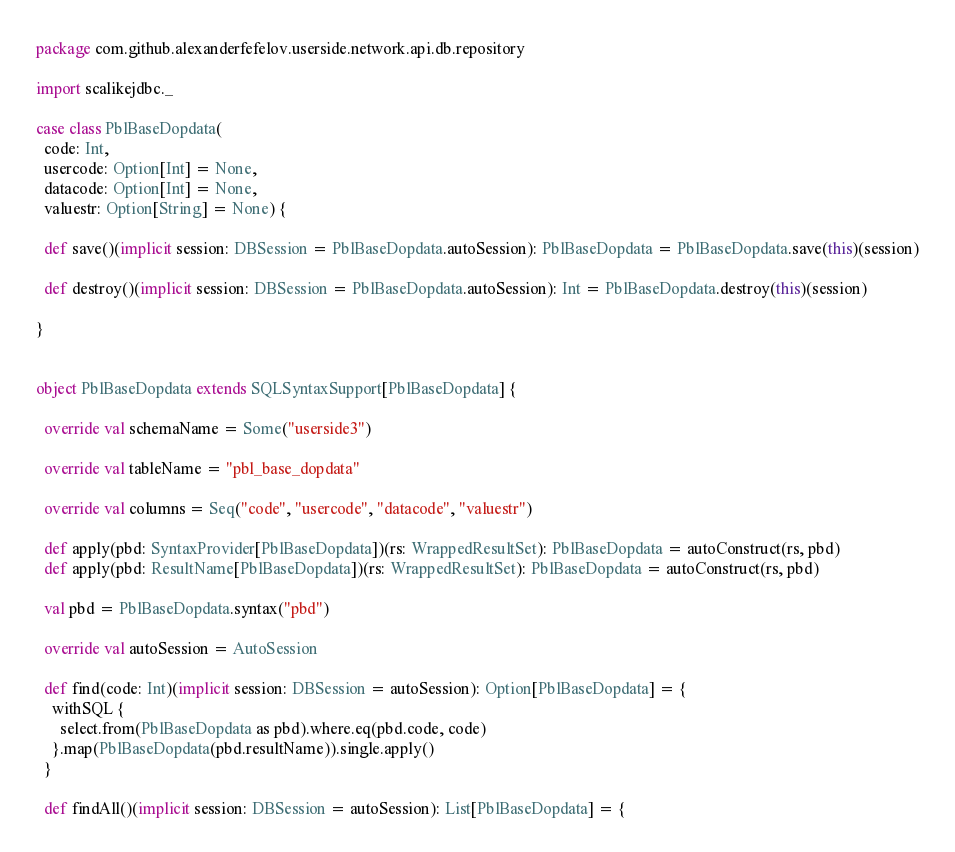Convert code to text. <code><loc_0><loc_0><loc_500><loc_500><_Scala_>package com.github.alexanderfefelov.userside.network.api.db.repository

import scalikejdbc._

case class PblBaseDopdata(
  code: Int,
  usercode: Option[Int] = None,
  datacode: Option[Int] = None,
  valuestr: Option[String] = None) {

  def save()(implicit session: DBSession = PblBaseDopdata.autoSession): PblBaseDopdata = PblBaseDopdata.save(this)(session)

  def destroy()(implicit session: DBSession = PblBaseDopdata.autoSession): Int = PblBaseDopdata.destroy(this)(session)

}


object PblBaseDopdata extends SQLSyntaxSupport[PblBaseDopdata] {

  override val schemaName = Some("userside3")

  override val tableName = "pbl_base_dopdata"

  override val columns = Seq("code", "usercode", "datacode", "valuestr")

  def apply(pbd: SyntaxProvider[PblBaseDopdata])(rs: WrappedResultSet): PblBaseDopdata = autoConstruct(rs, pbd)
  def apply(pbd: ResultName[PblBaseDopdata])(rs: WrappedResultSet): PblBaseDopdata = autoConstruct(rs, pbd)

  val pbd = PblBaseDopdata.syntax("pbd")

  override val autoSession = AutoSession

  def find(code: Int)(implicit session: DBSession = autoSession): Option[PblBaseDopdata] = {
    withSQL {
      select.from(PblBaseDopdata as pbd).where.eq(pbd.code, code)
    }.map(PblBaseDopdata(pbd.resultName)).single.apply()
  }

  def findAll()(implicit session: DBSession = autoSession): List[PblBaseDopdata] = {</code> 